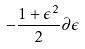Convert formula to latex. <formula><loc_0><loc_0><loc_500><loc_500>- \frac { 1 + \epsilon ^ { 2 } } { 2 } \partial \epsilon</formula> 